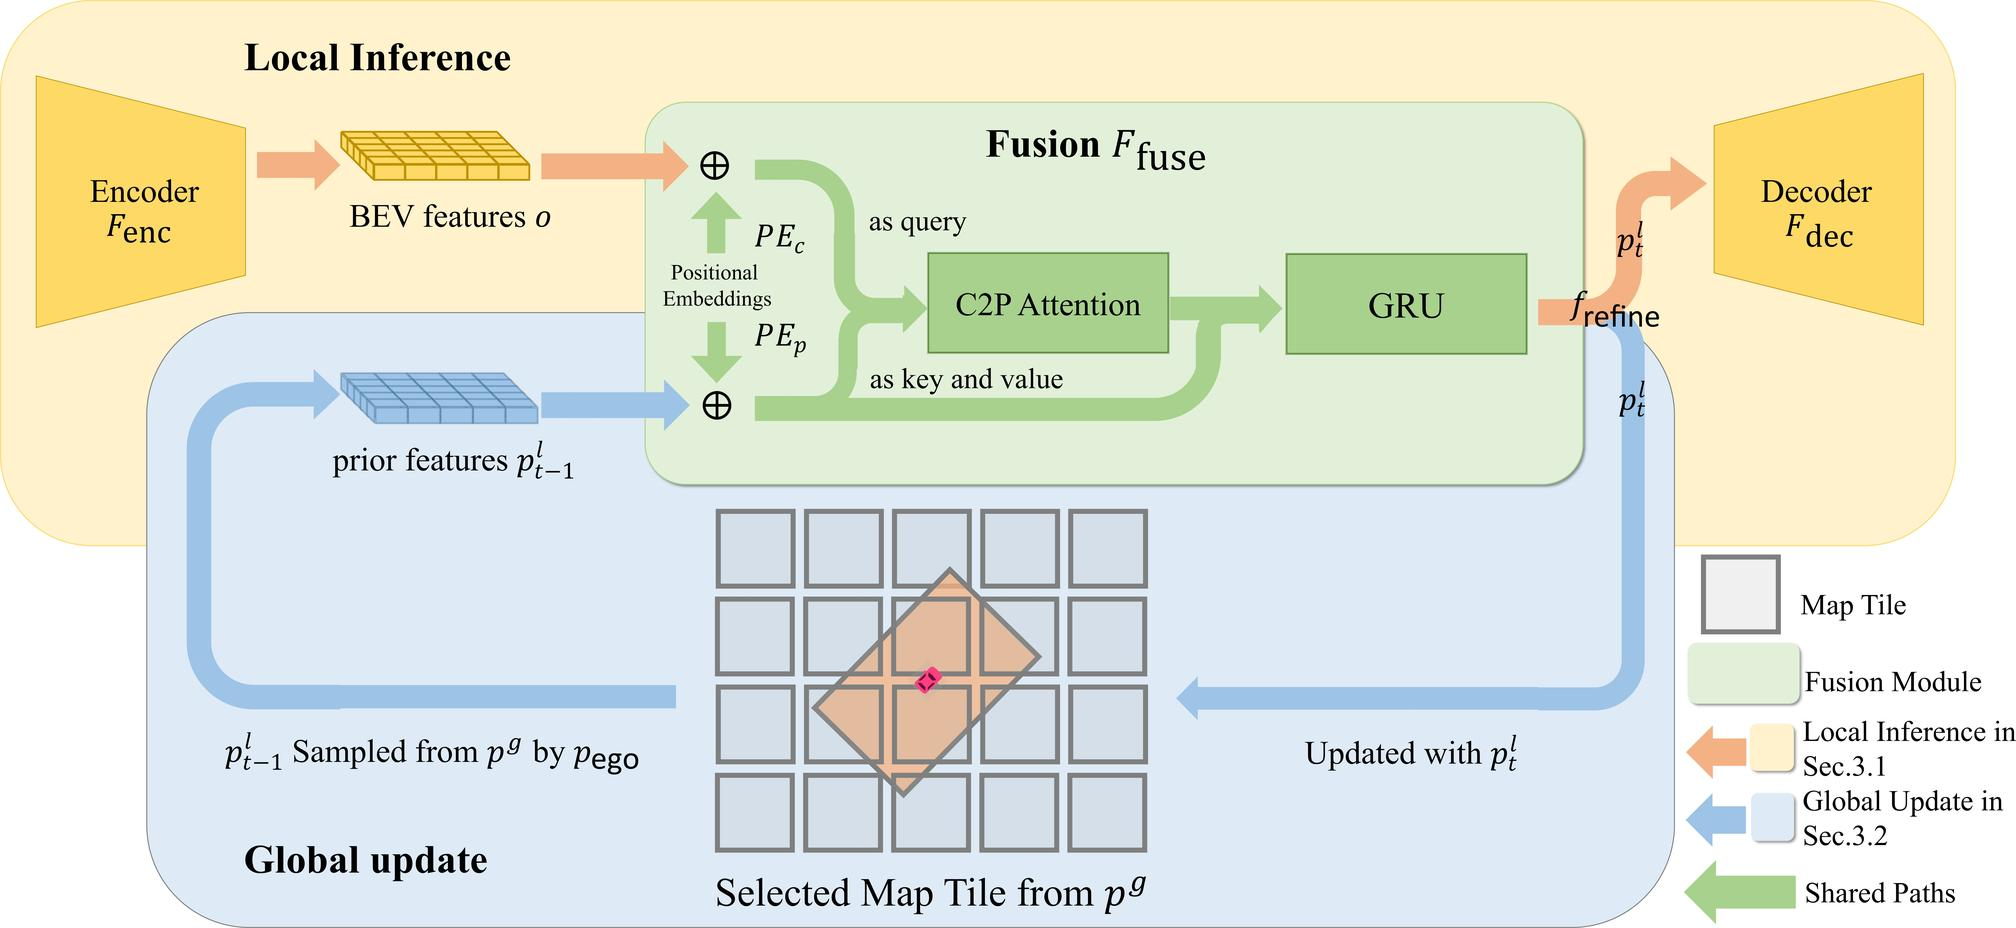Can you explain the role of positional embeddings in the architecture shown? Positional embeddings in this architecture play a fundamental role in ensuring that the spatial relationships and orientation within the input data are preserved and appropriately utilized. Specifically, positional embeddings (PEc and PEp) are used within the fusion module to inform the C2P Attention mechanism about the relative positions of different features. This allows the system to maintain an understanding of where objects are located relative to each other in the BEV space, which is crucial for tasks that require spatial awareness, such as navigation and object tracking in autonomous vehicles. 